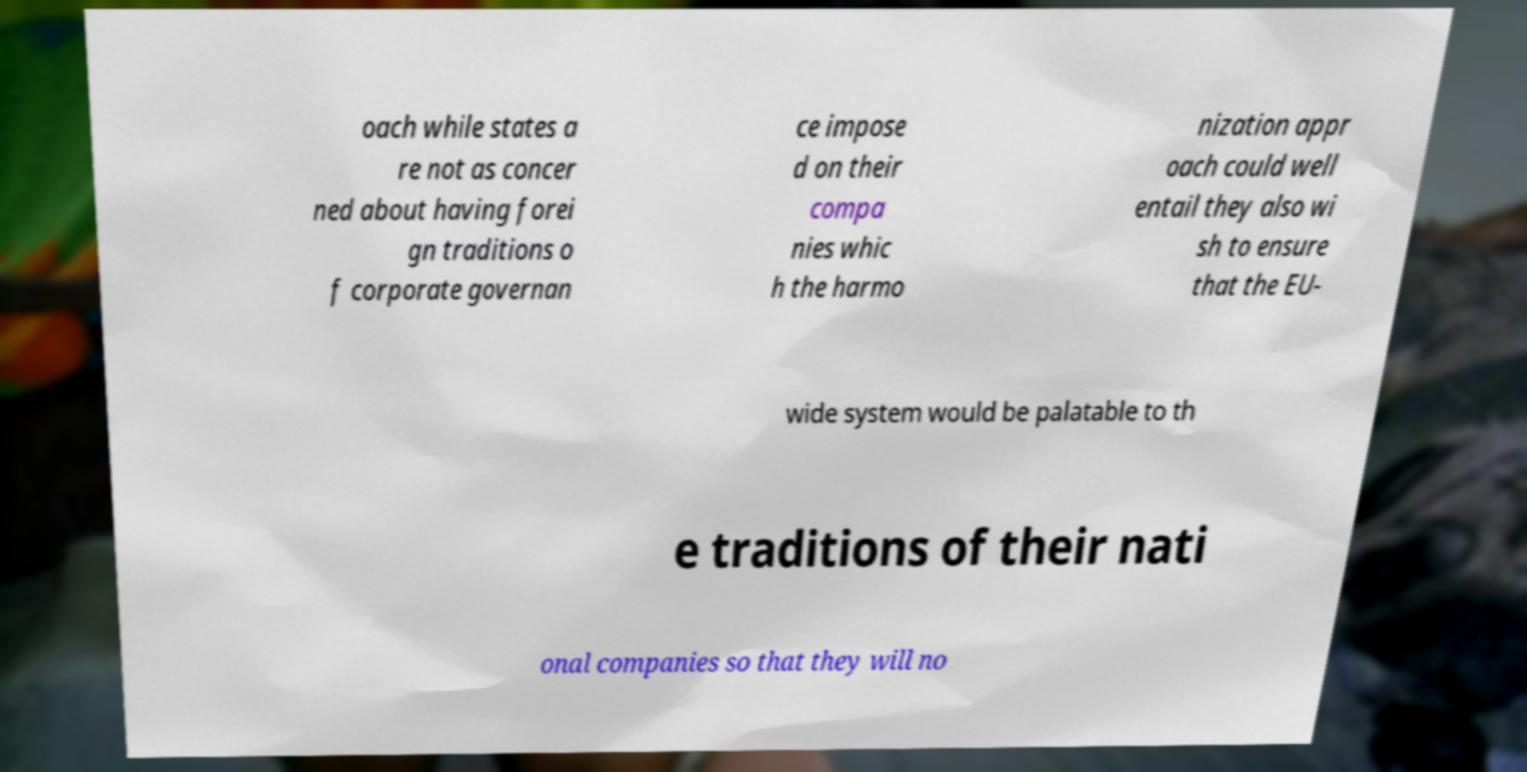Could you assist in decoding the text presented in this image and type it out clearly? oach while states a re not as concer ned about having forei gn traditions o f corporate governan ce impose d on their compa nies whic h the harmo nization appr oach could well entail they also wi sh to ensure that the EU- wide system would be palatable to th e traditions of their nati onal companies so that they will no 